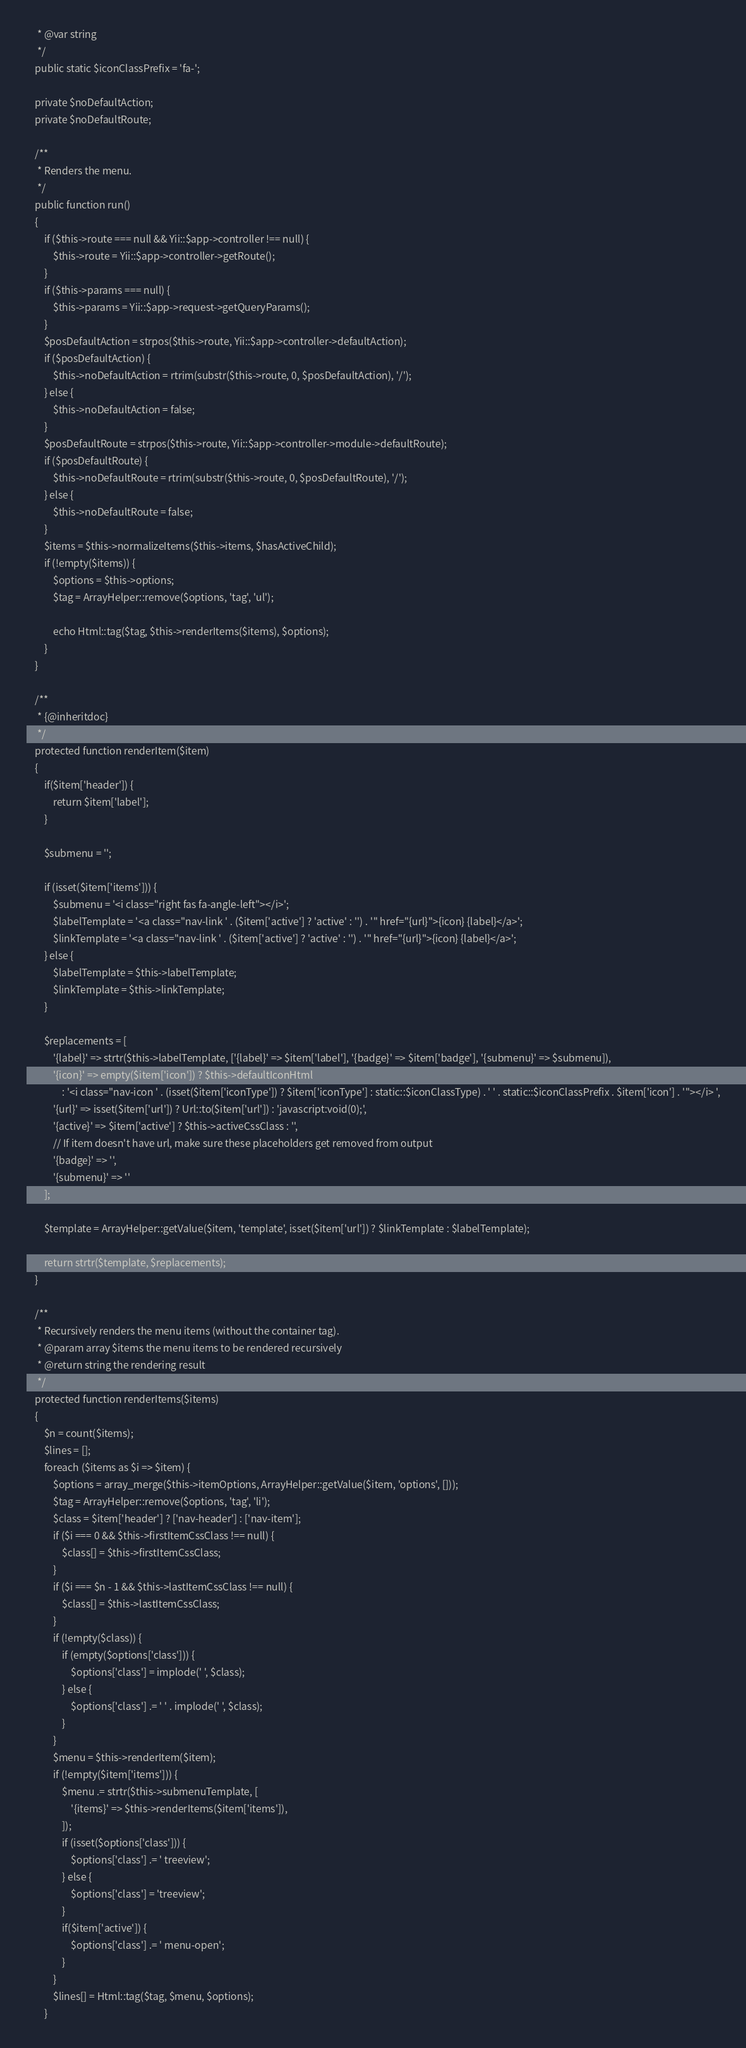<code> <loc_0><loc_0><loc_500><loc_500><_PHP_>     * @var string
     */
    public static $iconClassPrefix = 'fa-';

    private $noDefaultAction;
    private $noDefaultRoute;

    /**
     * Renders the menu.
     */
    public function run()
    {
        if ($this->route === null && Yii::$app->controller !== null) {
            $this->route = Yii::$app->controller->getRoute();
        }
        if ($this->params === null) {
            $this->params = Yii::$app->request->getQueryParams();
        }
        $posDefaultAction = strpos($this->route, Yii::$app->controller->defaultAction);
        if ($posDefaultAction) {
            $this->noDefaultAction = rtrim(substr($this->route, 0, $posDefaultAction), '/');
        } else {
            $this->noDefaultAction = false;
        }
        $posDefaultRoute = strpos($this->route, Yii::$app->controller->module->defaultRoute);
        if ($posDefaultRoute) {
            $this->noDefaultRoute = rtrim(substr($this->route, 0, $posDefaultRoute), '/');
        } else {
            $this->noDefaultRoute = false;
        }
        $items = $this->normalizeItems($this->items, $hasActiveChild);
        if (!empty($items)) {
            $options = $this->options;
            $tag = ArrayHelper::remove($options, 'tag', 'ul');

            echo Html::tag($tag, $this->renderItems($items), $options);
        }
    }

    /**
     * {@inheritdoc}
     */
    protected function renderItem($item)
    {
        if($item['header']) {
            return $item['label'];
        }

        $submenu = '';

        if (isset($item['items'])) {
            $submenu = '<i class="right fas fa-angle-left"></i>';
            $labelTemplate = '<a class="nav-link ' . ($item['active'] ? 'active' : '') . '" href="{url}">{icon} {label}</a>';
            $linkTemplate = '<a class="nav-link ' . ($item['active'] ? 'active' : '') . '" href="{url}">{icon} {label}</a>';
        } else {
            $labelTemplate = $this->labelTemplate;
            $linkTemplate = $this->linkTemplate;
        }

        $replacements = [
            '{label}' => strtr($this->labelTemplate, ['{label}' => $item['label'], '{badge}' => $item['badge'], '{submenu}' => $submenu]),
            '{icon}' => empty($item['icon']) ? $this->defaultIconHtml
                : '<i class="nav-icon ' . (isset($item['iconType']) ? $item['iconType'] : static::$iconClassType) . ' ' . static::$iconClassPrefix . $item['icon'] . '"></i> ',
            '{url}' => isset($item['url']) ? Url::to($item['url']) : 'javascript:void(0);',
            '{active}' => $item['active'] ? $this->activeCssClass : '',
            // If item doesn't have url, make sure these placeholders get removed from output
            '{badge}' => '',
            '{submenu}' => ''
        ];

        $template = ArrayHelper::getValue($item, 'template', isset($item['url']) ? $linkTemplate : $labelTemplate);

        return strtr($template, $replacements);
    }

    /**
     * Recursively renders the menu items (without the container tag).
     * @param array $items the menu items to be rendered recursively
     * @return string the rendering result
     */
    protected function renderItems($items)
    {
        $n = count($items);
        $lines = [];
        foreach ($items as $i => $item) {
            $options = array_merge($this->itemOptions, ArrayHelper::getValue($item, 'options', []));
            $tag = ArrayHelper::remove($options, 'tag', 'li');
            $class = $item['header'] ? ['nav-header'] : ['nav-item'];
            if ($i === 0 && $this->firstItemCssClass !== null) {
                $class[] = $this->firstItemCssClass;
            }
            if ($i === $n - 1 && $this->lastItemCssClass !== null) {
                $class[] = $this->lastItemCssClass;
            }
            if (!empty($class)) {
                if (empty($options['class'])) {
                    $options['class'] = implode(' ', $class);
                } else {
                    $options['class'] .= ' ' . implode(' ', $class);
                }
            }
            $menu = $this->renderItem($item);
            if (!empty($item['items'])) {
                $menu .= strtr($this->submenuTemplate, [
                    '{items}' => $this->renderItems($item['items']),
                ]);
				if (isset($options['class'])) {
					$options['class'] .= ' treeview';
				} else {
					$options['class'] = 'treeview';
				}
                if($item['active']) {
                    $options['class'] .= ' menu-open';
                }
            }
            $lines[] = Html::tag($tag, $menu, $options);
        }</code> 